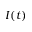Convert formula to latex. <formula><loc_0><loc_0><loc_500><loc_500>I ( t )</formula> 